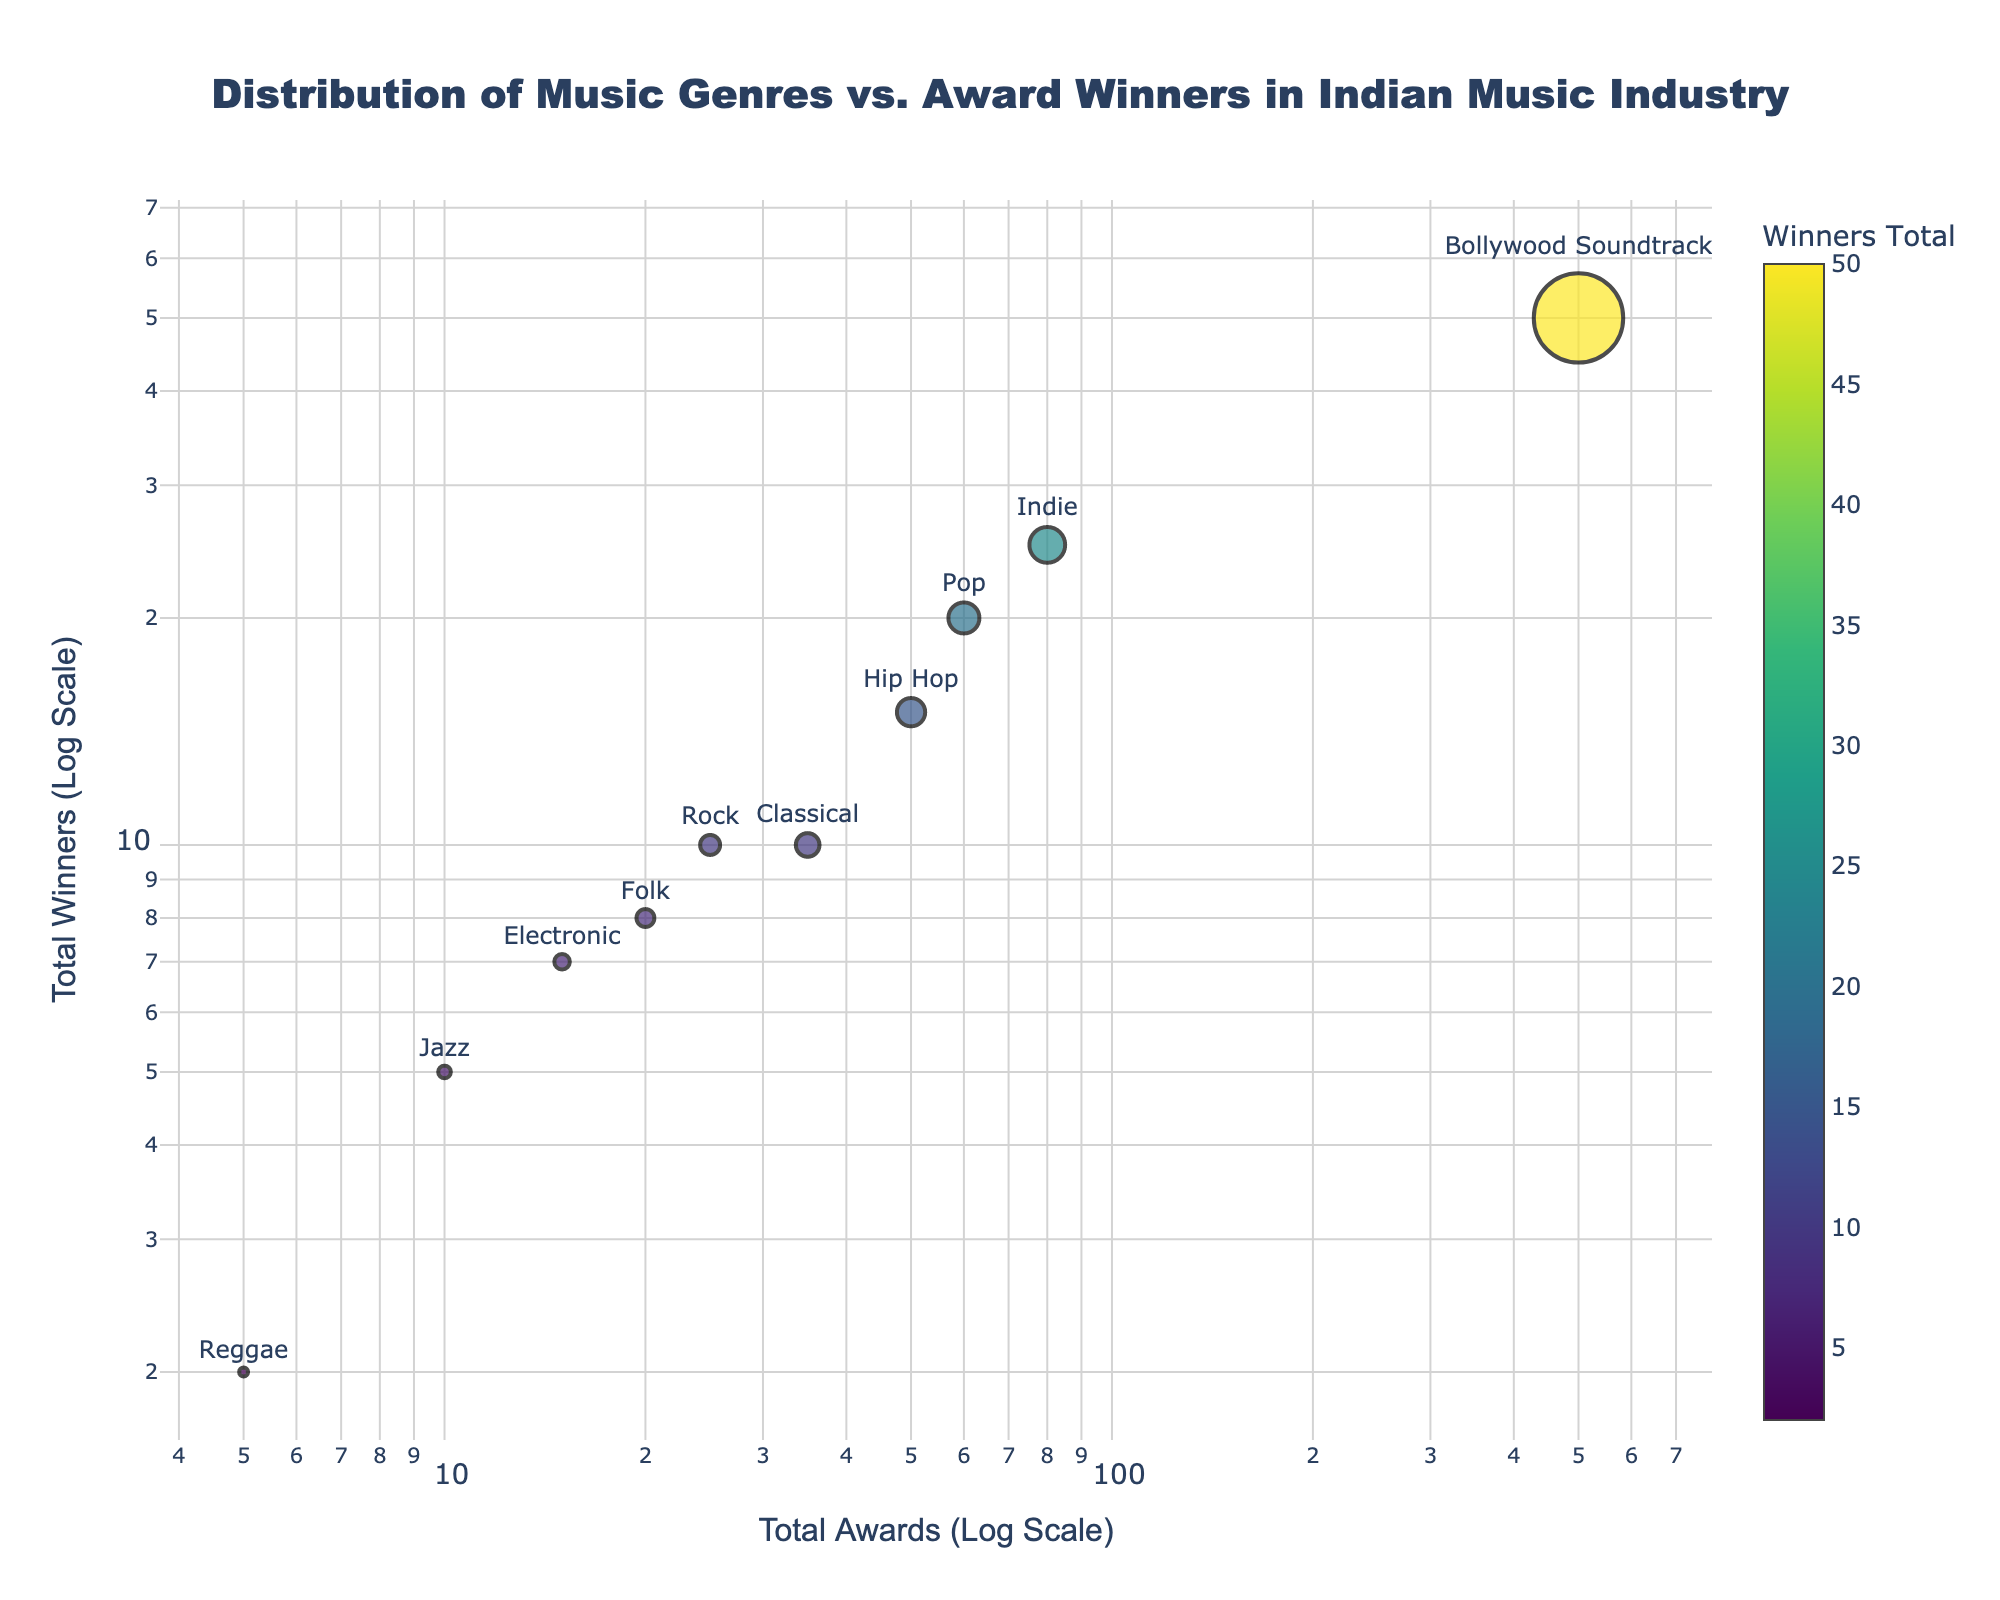What is the genre with the highest total awards? The genre with the highest total awards can be identified by looking at the x-axis position with the largest value. The Bollywod Soundtrack genre has the highest value along the x-axis.
Answer: Bollywood Soundtrack What genre has the lowest number of winners? The genre with the lowest number of winners can be identified by looking at the data point closest to the bottom of the y-axis. This is the Reggae genre.
Answer: Reggae Which genre has more winners: Indie or Hip Hop? To compare the number of winners, look at the y-axis positions of the Indie and Hip Hop genres. Indie has 25 winners, whereas Hip Hop has 15.
Answer: Indie How many genres have at least 10 winners? To find genres with at least 10 winners, count the data points that have y-axis values of 10 or greater. The genres are Bollywood Soundtrack, Classical, Indie, Hip Hop, Pop, and Rock.
Answer: 6 Which genre has more awards, Pop or Rock? To compare the number of awards, look at the x-axis positions of Pop and Rock. Pop has 60 awards, whereas Rock has 25.
Answer: Pop What is the difference in the number of winners between Classical and Folk genres? The number of winners for Classical is 10 and for Folk is 8. The difference is 10 - 8.
Answer: 2 What is the total number of awards for genres with fewer than 10 winners? Add the number of awards for genres with winners fewer than 10: Electronic (15), Jazz (10), and Reggae (5). The total is 15 + 10 + 5.
Answer: 30 Which genre shows the greatest disparity between total awards and total winners? Find the genre with the largest difference between its x-axis (total awards) and y-axis (total winners). Bollywood Soundtrack has the most awards (500) compared to its winners (50) resulting in a disparity of 450.
Answer: Bollywood Soundtrack Are there more genres with award totals greater than 50 or winners totals greater than 20? Count the genres with award totals greater than 50: Bollywood Soundtrack, Indie, and Pop (3). Count the genres with winner totals greater than 20: Bollywood Soundtrack and Indie (2).
Answer: Award totals greater than 50 What genres cluster around the award total of 25? Look for data points closest to the x-axis value of 25. Rock and Folk are the genres approximately near this value.
Answer: Rock, Folk 